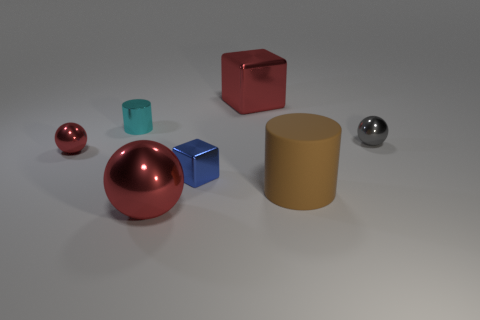Is there anything else that is the same shape as the gray shiny object?
Make the answer very short. Yes. Is the number of big red metal cubes less than the number of large cyan matte objects?
Provide a succinct answer. No. There is a ball that is on the right side of the big red cube behind the large sphere; what color is it?
Give a very brief answer. Gray. What material is the cylinder that is in front of the metallic sphere that is behind the metal sphere that is on the left side of the cyan metal object?
Provide a succinct answer. Rubber. Is the size of the object to the left of the cyan metal cylinder the same as the blue shiny cube?
Your answer should be compact. Yes. What is the material of the cylinder that is in front of the blue cube?
Your answer should be compact. Rubber. Are there more cyan shiny things than tiny blue shiny balls?
Give a very brief answer. Yes. What number of things are large shiny things that are in front of the cyan cylinder or large gray metallic blocks?
Provide a short and direct response. 1. There is a red metal thing that is in front of the tiny red shiny thing; what number of small balls are on the left side of it?
Ensure brevity in your answer.  1. There is a cylinder that is in front of the small metallic ball behind the red thing left of the cyan metallic object; what size is it?
Ensure brevity in your answer.  Large. 